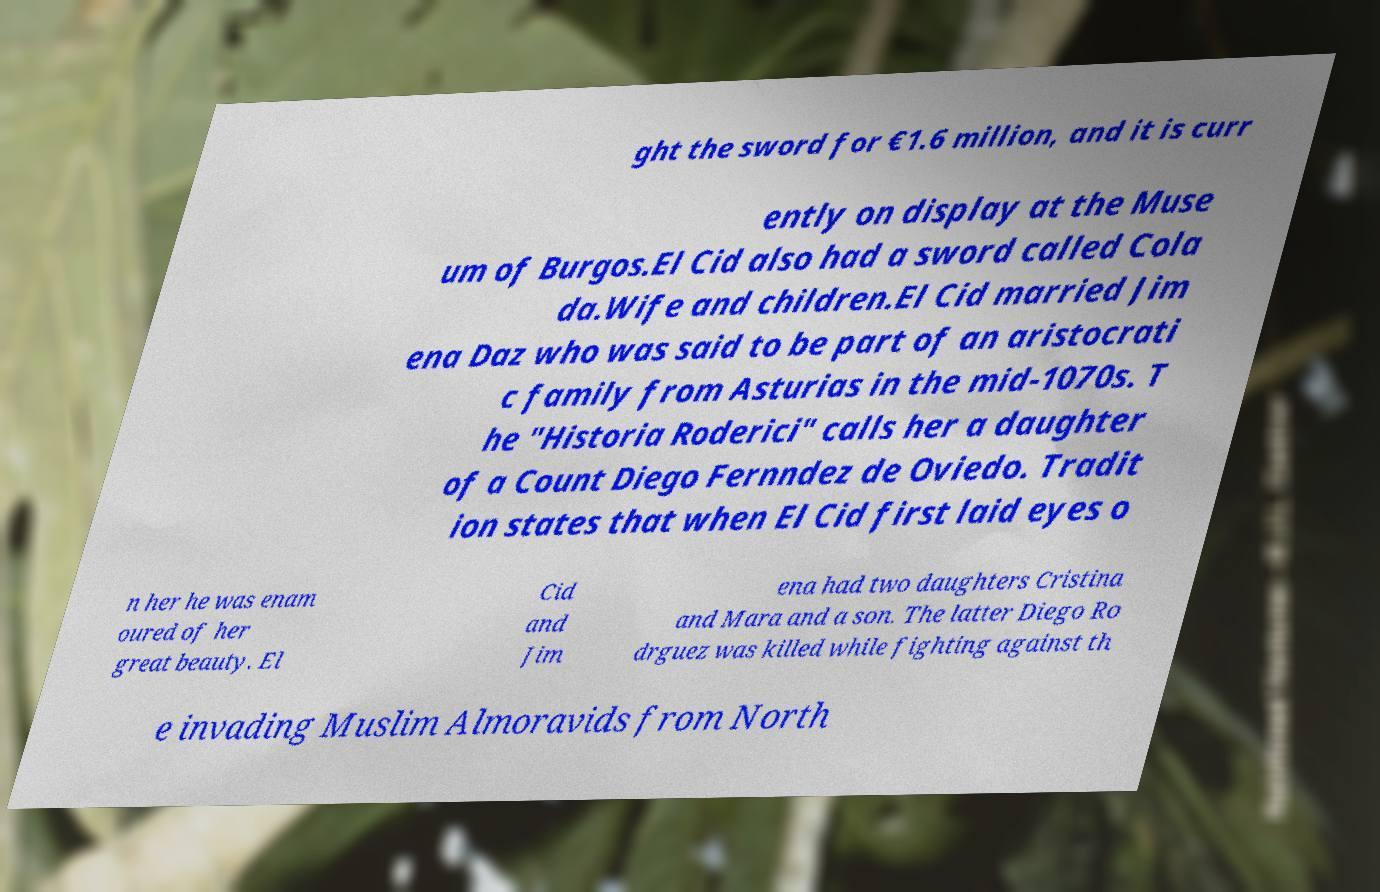Can you accurately transcribe the text from the provided image for me? ght the sword for €1.6 million, and it is curr ently on display at the Muse um of Burgos.El Cid also had a sword called Cola da.Wife and children.El Cid married Jim ena Daz who was said to be part of an aristocrati c family from Asturias in the mid-1070s. T he "Historia Roderici" calls her a daughter of a Count Diego Fernndez de Oviedo. Tradit ion states that when El Cid first laid eyes o n her he was enam oured of her great beauty. El Cid and Jim ena had two daughters Cristina and Mara and a son. The latter Diego Ro drguez was killed while fighting against th e invading Muslim Almoravids from North 